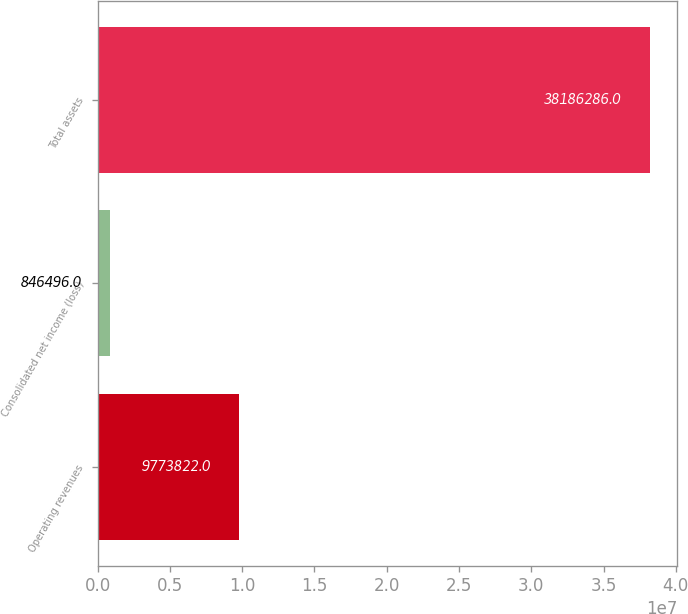Convert chart to OTSL. <chart><loc_0><loc_0><loc_500><loc_500><bar_chart><fcel>Operating revenues<fcel>Consolidated net income (loss)<fcel>Total assets<nl><fcel>9.77382e+06<fcel>846496<fcel>3.81863e+07<nl></chart> 